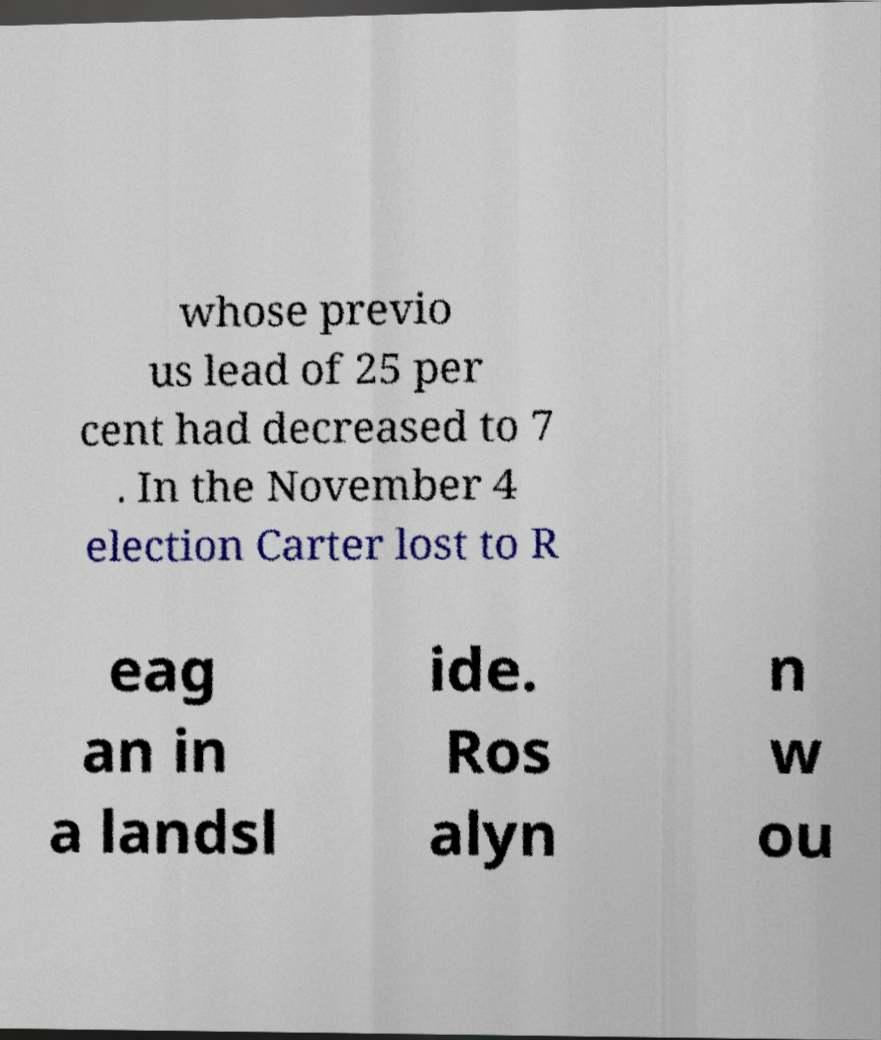What messages or text are displayed in this image? I need them in a readable, typed format. whose previo us lead of 25 per cent had decreased to 7 . In the November 4 election Carter lost to R eag an in a landsl ide. Ros alyn n w ou 